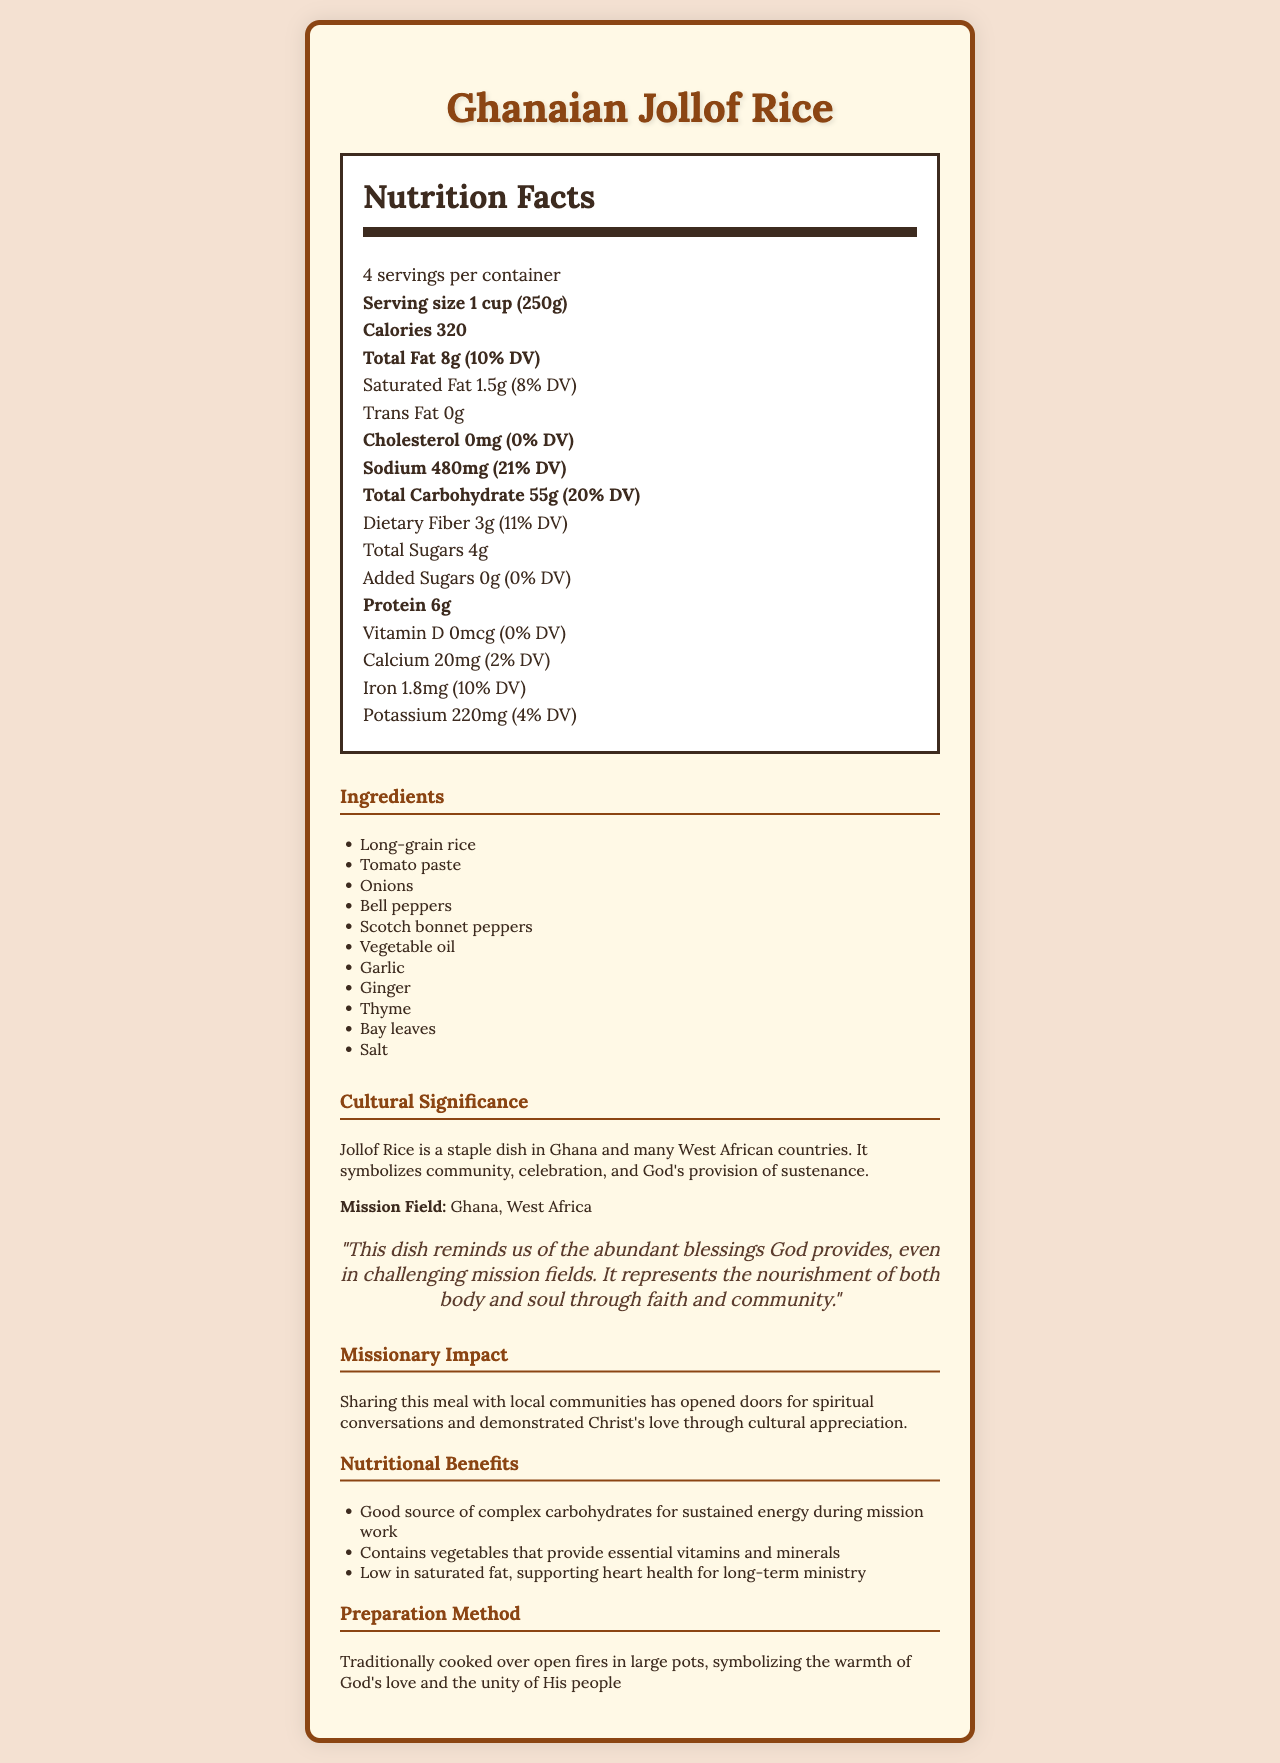what is the serving size of Ghanaian Jollof Rice? The serving size is clearly mentioned as 1 cup (250g) in the Nutrition Facts.
Answer: 1 cup (250g) how many servings are there per container? The document states that there are 4 servings per container.
Answer: 4 how many calories are in one serving of Ghanaian Jollof Rice? The Nutrition Facts indicate that one serving contains 320 calories.
Answer: 320 what amount of total fat is in one serving and what percentage of the daily value does it represent? The total fat content per serving is 8g, which represents 10% of the daily value.
Answer: 8g (10% DV) does Ghanaian Jollof Rice contain any trans fat? The Nutrition Facts report 0g of trans fat.
Answer: No how much sodium is present in one serving of Ghanaian Jollof Rice? The sodium content per serving is listed as 480mg.
Answer: 480mg what vitamins and minerals are mentioned in the Nutrition Facts, and what are their daily values? The vitamins and minerals mentioned are Vitamin D (0% DV), Calcium (2% DV), Iron (10% DV), and Potassium (4% DV).
Answer: Vitamin D (0%), Calcium (2%), Iron (10%), Potassium (4%) which of the following is not an ingredient in Ghanaian Jollof Rice?
A. Tomato paste
B. Thyme
C. Carrots The ingredient list includes Tomato paste and Thyme, but Carrots are not mentioned.
Answer: C. Carrots according to the document, what is the cultural significance of Ghanaian Jollof Rice? The document explains that Jollof Rice is important in Ghanaian culture and symbolizes community, celebration, and God's provision.
Answer: It symbolizes community, celebration, and God's provision of sustenance based on the document, describe the spiritual reflection associated with Ghanaian Jollof Rice. The spiritual reflection in the document states that the dish symbolizes God's abundant blessings and the nourishment of both body and soul through faith and community.
Answer: Ghanaian Jollof Rice reminds us of the abundant blessings God provides and represents the nourishment of both body and soul through faith and community. is protein content in Ghanaian Jollof Rice high or low compared to the total carbohydrate content? The protein content is 6g per serving, which is much lower compared to the total carbohydrate content of 55g per serving.
Answer: Low how is Ghanaian Jollof Rice traditionally prepared, and what does this method symbolize? The preparation method mentioned is over open fires in large pots, and it symbolizes the warmth of God's love and unity among His people.
Answer: Traditionally cooked over open fires in large pots, symbolizing the warmth of God's love and the unity of His people what are some nutritional benefits of consuming Ghanaian Jollof Rice during mission work? The document lists several nutritional benefits: it’s a good source of complex carbohydrates, contains essential vitamins and minerals, and is low in saturated fat.
Answer: Good source of complex carbohydrates, contains essential vitamins and minerals, low in saturated fat what is the main idea of the document? The main idea is to convey detailed information about Ghanaian Jollof Rice, covering various aspects like nutrition, culture, spirituality, and how it aids in missionary work.
Answer: The document provides comprehensive information about Ghanaian Jollof Rice, including its nutritional facts, ingredients, cultural significance, spiritual reflection, missionary impact, and preparation method. how much vitamin C is in Ghanaian Jollof Rice? The document does not provide any information about the vitamin C content in Ghanaian Jollof Rice.
Answer: Not enough information 